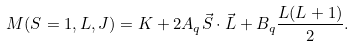<formula> <loc_0><loc_0><loc_500><loc_500>M ( S = 1 , L , J ) = K + 2 A _ { q } \vec { S } \cdot \vec { L } + B _ { q } \frac { L ( L + 1 ) } { 2 } .</formula> 